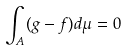<formula> <loc_0><loc_0><loc_500><loc_500>\int _ { A } ( g - f ) d \mu = 0</formula> 